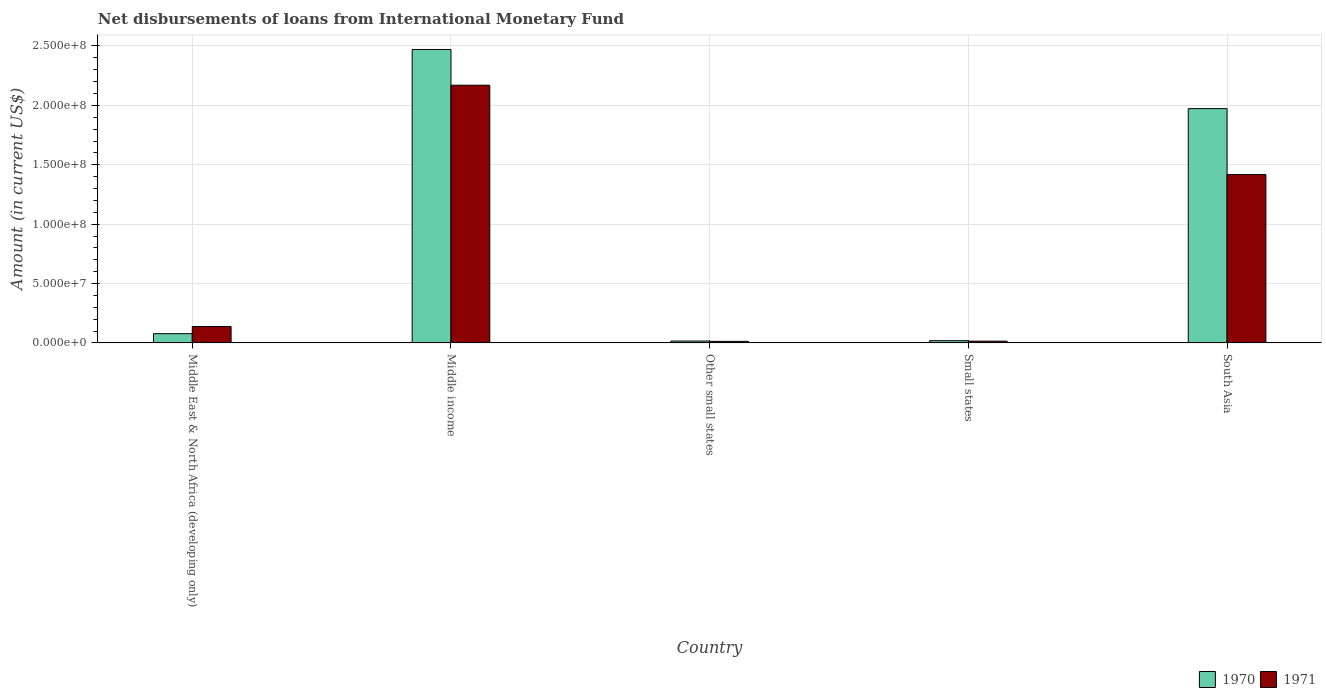How many groups of bars are there?
Ensure brevity in your answer.  5. Are the number of bars per tick equal to the number of legend labels?
Keep it short and to the point. Yes. Are the number of bars on each tick of the X-axis equal?
Provide a succinct answer. Yes. How many bars are there on the 1st tick from the left?
Offer a very short reply. 2. How many bars are there on the 1st tick from the right?
Provide a short and direct response. 2. What is the label of the 1st group of bars from the left?
Make the answer very short. Middle East & North Africa (developing only). What is the amount of loans disbursed in 1970 in Other small states?
Ensure brevity in your answer.  1.61e+06. Across all countries, what is the maximum amount of loans disbursed in 1970?
Keep it short and to the point. 2.47e+08. Across all countries, what is the minimum amount of loans disbursed in 1971?
Keep it short and to the point. 1.32e+06. In which country was the amount of loans disbursed in 1970 maximum?
Your answer should be very brief. Middle income. In which country was the amount of loans disbursed in 1971 minimum?
Offer a very short reply. Other small states. What is the total amount of loans disbursed in 1971 in the graph?
Give a very brief answer. 3.75e+08. What is the difference between the amount of loans disbursed in 1971 in Middle East & North Africa (developing only) and that in South Asia?
Your answer should be compact. -1.28e+08. What is the difference between the amount of loans disbursed in 1971 in Middle East & North Africa (developing only) and the amount of loans disbursed in 1970 in South Asia?
Your answer should be compact. -1.83e+08. What is the average amount of loans disbursed in 1971 per country?
Keep it short and to the point. 7.51e+07. What is the difference between the amount of loans disbursed of/in 1971 and amount of loans disbursed of/in 1970 in Middle East & North Africa (developing only)?
Provide a succinct answer. 6.03e+06. In how many countries, is the amount of loans disbursed in 1970 greater than 210000000 US$?
Your answer should be compact. 1. What is the ratio of the amount of loans disbursed in 1971 in Middle East & North Africa (developing only) to that in Other small states?
Provide a succinct answer. 10.45. What is the difference between the highest and the second highest amount of loans disbursed in 1971?
Make the answer very short. 7.52e+07. What is the difference between the highest and the lowest amount of loans disbursed in 1970?
Offer a very short reply. 2.45e+08. In how many countries, is the amount of loans disbursed in 1970 greater than the average amount of loans disbursed in 1970 taken over all countries?
Give a very brief answer. 2. Is the sum of the amount of loans disbursed in 1970 in Middle East & North Africa (developing only) and Small states greater than the maximum amount of loans disbursed in 1971 across all countries?
Provide a succinct answer. No. What does the 1st bar from the left in Middle East & North Africa (developing only) represents?
Your answer should be very brief. 1970. How many bars are there?
Provide a short and direct response. 10. Are all the bars in the graph horizontal?
Provide a succinct answer. No. How many countries are there in the graph?
Your response must be concise. 5. What is the difference between two consecutive major ticks on the Y-axis?
Your answer should be compact. 5.00e+07. Does the graph contain grids?
Offer a very short reply. Yes. Where does the legend appear in the graph?
Provide a succinct answer. Bottom right. How are the legend labels stacked?
Give a very brief answer. Horizontal. What is the title of the graph?
Your answer should be very brief. Net disbursements of loans from International Monetary Fund. What is the label or title of the Y-axis?
Your response must be concise. Amount (in current US$). What is the Amount (in current US$) in 1970 in Middle East & North Africa (developing only)?
Ensure brevity in your answer.  7.79e+06. What is the Amount (in current US$) in 1971 in Middle East & North Africa (developing only)?
Your answer should be very brief. 1.38e+07. What is the Amount (in current US$) of 1970 in Middle income?
Your answer should be compact. 2.47e+08. What is the Amount (in current US$) in 1971 in Middle income?
Offer a very short reply. 2.17e+08. What is the Amount (in current US$) of 1970 in Other small states?
Make the answer very short. 1.61e+06. What is the Amount (in current US$) of 1971 in Other small states?
Your answer should be very brief. 1.32e+06. What is the Amount (in current US$) in 1970 in Small states?
Provide a short and direct response. 1.91e+06. What is the Amount (in current US$) in 1971 in Small states?
Ensure brevity in your answer.  1.50e+06. What is the Amount (in current US$) in 1970 in South Asia?
Your answer should be compact. 1.97e+08. What is the Amount (in current US$) of 1971 in South Asia?
Give a very brief answer. 1.42e+08. Across all countries, what is the maximum Amount (in current US$) in 1970?
Your response must be concise. 2.47e+08. Across all countries, what is the maximum Amount (in current US$) of 1971?
Offer a terse response. 2.17e+08. Across all countries, what is the minimum Amount (in current US$) in 1970?
Your response must be concise. 1.61e+06. Across all countries, what is the minimum Amount (in current US$) of 1971?
Offer a terse response. 1.32e+06. What is the total Amount (in current US$) in 1970 in the graph?
Offer a terse response. 4.56e+08. What is the total Amount (in current US$) in 1971 in the graph?
Provide a short and direct response. 3.75e+08. What is the difference between the Amount (in current US$) in 1970 in Middle East & North Africa (developing only) and that in Middle income?
Your answer should be very brief. -2.39e+08. What is the difference between the Amount (in current US$) in 1971 in Middle East & North Africa (developing only) and that in Middle income?
Offer a very short reply. -2.03e+08. What is the difference between the Amount (in current US$) in 1970 in Middle East & North Africa (developing only) and that in Other small states?
Offer a very short reply. 6.19e+06. What is the difference between the Amount (in current US$) of 1971 in Middle East & North Africa (developing only) and that in Other small states?
Keep it short and to the point. 1.25e+07. What is the difference between the Amount (in current US$) of 1970 in Middle East & North Africa (developing only) and that in Small states?
Offer a very short reply. 5.89e+06. What is the difference between the Amount (in current US$) in 1971 in Middle East & North Africa (developing only) and that in Small states?
Provide a short and direct response. 1.23e+07. What is the difference between the Amount (in current US$) in 1970 in Middle East & North Africa (developing only) and that in South Asia?
Provide a succinct answer. -1.89e+08. What is the difference between the Amount (in current US$) in 1971 in Middle East & North Africa (developing only) and that in South Asia?
Offer a very short reply. -1.28e+08. What is the difference between the Amount (in current US$) of 1970 in Middle income and that in Other small states?
Make the answer very short. 2.45e+08. What is the difference between the Amount (in current US$) in 1971 in Middle income and that in Other small states?
Your answer should be compact. 2.16e+08. What is the difference between the Amount (in current US$) of 1970 in Middle income and that in Small states?
Your answer should be compact. 2.45e+08. What is the difference between the Amount (in current US$) in 1971 in Middle income and that in Small states?
Offer a very short reply. 2.15e+08. What is the difference between the Amount (in current US$) of 1970 in Middle income and that in South Asia?
Offer a terse response. 4.97e+07. What is the difference between the Amount (in current US$) of 1971 in Middle income and that in South Asia?
Your answer should be very brief. 7.52e+07. What is the difference between the Amount (in current US$) of 1970 in Other small states and that in Small states?
Ensure brevity in your answer.  -2.99e+05. What is the difference between the Amount (in current US$) of 1971 in Other small states and that in Small states?
Your answer should be very brief. -1.76e+05. What is the difference between the Amount (in current US$) in 1970 in Other small states and that in South Asia?
Give a very brief answer. -1.96e+08. What is the difference between the Amount (in current US$) in 1971 in Other small states and that in South Asia?
Your answer should be very brief. -1.40e+08. What is the difference between the Amount (in current US$) of 1970 in Small states and that in South Asia?
Your answer should be compact. -1.95e+08. What is the difference between the Amount (in current US$) in 1971 in Small states and that in South Asia?
Make the answer very short. -1.40e+08. What is the difference between the Amount (in current US$) of 1970 in Middle East & North Africa (developing only) and the Amount (in current US$) of 1971 in Middle income?
Make the answer very short. -2.09e+08. What is the difference between the Amount (in current US$) of 1970 in Middle East & North Africa (developing only) and the Amount (in current US$) of 1971 in Other small states?
Make the answer very short. 6.47e+06. What is the difference between the Amount (in current US$) of 1970 in Middle East & North Africa (developing only) and the Amount (in current US$) of 1971 in Small states?
Your response must be concise. 6.30e+06. What is the difference between the Amount (in current US$) in 1970 in Middle East & North Africa (developing only) and the Amount (in current US$) in 1971 in South Asia?
Provide a succinct answer. -1.34e+08. What is the difference between the Amount (in current US$) in 1970 in Middle income and the Amount (in current US$) in 1971 in Other small states?
Offer a very short reply. 2.46e+08. What is the difference between the Amount (in current US$) of 1970 in Middle income and the Amount (in current US$) of 1971 in Small states?
Provide a succinct answer. 2.46e+08. What is the difference between the Amount (in current US$) in 1970 in Middle income and the Amount (in current US$) in 1971 in South Asia?
Ensure brevity in your answer.  1.05e+08. What is the difference between the Amount (in current US$) of 1970 in Other small states and the Amount (in current US$) of 1971 in Small states?
Your answer should be very brief. 1.09e+05. What is the difference between the Amount (in current US$) of 1970 in Other small states and the Amount (in current US$) of 1971 in South Asia?
Your answer should be compact. -1.40e+08. What is the difference between the Amount (in current US$) of 1970 in Small states and the Amount (in current US$) of 1971 in South Asia?
Your answer should be very brief. -1.40e+08. What is the average Amount (in current US$) of 1970 per country?
Your answer should be very brief. 9.11e+07. What is the average Amount (in current US$) in 1971 per country?
Keep it short and to the point. 7.51e+07. What is the difference between the Amount (in current US$) in 1970 and Amount (in current US$) in 1971 in Middle East & North Africa (developing only)?
Keep it short and to the point. -6.03e+06. What is the difference between the Amount (in current US$) in 1970 and Amount (in current US$) in 1971 in Middle income?
Give a very brief answer. 3.00e+07. What is the difference between the Amount (in current US$) in 1970 and Amount (in current US$) in 1971 in Other small states?
Offer a terse response. 2.85e+05. What is the difference between the Amount (in current US$) in 1970 and Amount (in current US$) in 1971 in Small states?
Offer a terse response. 4.08e+05. What is the difference between the Amount (in current US$) in 1970 and Amount (in current US$) in 1971 in South Asia?
Give a very brief answer. 5.55e+07. What is the ratio of the Amount (in current US$) of 1970 in Middle East & North Africa (developing only) to that in Middle income?
Your answer should be very brief. 0.03. What is the ratio of the Amount (in current US$) of 1971 in Middle East & North Africa (developing only) to that in Middle income?
Offer a terse response. 0.06. What is the ratio of the Amount (in current US$) in 1970 in Middle East & North Africa (developing only) to that in Other small states?
Make the answer very short. 4.85. What is the ratio of the Amount (in current US$) of 1971 in Middle East & North Africa (developing only) to that in Other small states?
Offer a terse response. 10.45. What is the ratio of the Amount (in current US$) in 1970 in Middle East & North Africa (developing only) to that in Small states?
Give a very brief answer. 4.09. What is the ratio of the Amount (in current US$) of 1971 in Middle East & North Africa (developing only) to that in Small states?
Make the answer very short. 9.23. What is the ratio of the Amount (in current US$) of 1970 in Middle East & North Africa (developing only) to that in South Asia?
Provide a succinct answer. 0.04. What is the ratio of the Amount (in current US$) of 1971 in Middle East & North Africa (developing only) to that in South Asia?
Give a very brief answer. 0.1. What is the ratio of the Amount (in current US$) in 1970 in Middle income to that in Other small states?
Your answer should be very brief. 153.71. What is the ratio of the Amount (in current US$) in 1971 in Middle income to that in Other small states?
Give a very brief answer. 164.14. What is the ratio of the Amount (in current US$) in 1970 in Middle income to that in Small states?
Give a very brief answer. 129.6. What is the ratio of the Amount (in current US$) in 1971 in Middle income to that in Small states?
Provide a short and direct response. 144.85. What is the ratio of the Amount (in current US$) of 1970 in Middle income to that in South Asia?
Give a very brief answer. 1.25. What is the ratio of the Amount (in current US$) of 1971 in Middle income to that in South Asia?
Your answer should be very brief. 1.53. What is the ratio of the Amount (in current US$) of 1970 in Other small states to that in Small states?
Ensure brevity in your answer.  0.84. What is the ratio of the Amount (in current US$) in 1971 in Other small states to that in Small states?
Provide a succinct answer. 0.88. What is the ratio of the Amount (in current US$) of 1970 in Other small states to that in South Asia?
Offer a terse response. 0.01. What is the ratio of the Amount (in current US$) of 1971 in Other small states to that in South Asia?
Your answer should be very brief. 0.01. What is the ratio of the Amount (in current US$) of 1970 in Small states to that in South Asia?
Make the answer very short. 0.01. What is the ratio of the Amount (in current US$) of 1971 in Small states to that in South Asia?
Make the answer very short. 0.01. What is the difference between the highest and the second highest Amount (in current US$) of 1970?
Keep it short and to the point. 4.97e+07. What is the difference between the highest and the second highest Amount (in current US$) in 1971?
Your answer should be very brief. 7.52e+07. What is the difference between the highest and the lowest Amount (in current US$) in 1970?
Make the answer very short. 2.45e+08. What is the difference between the highest and the lowest Amount (in current US$) of 1971?
Your answer should be very brief. 2.16e+08. 